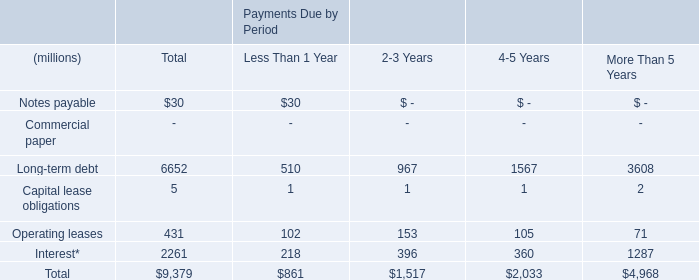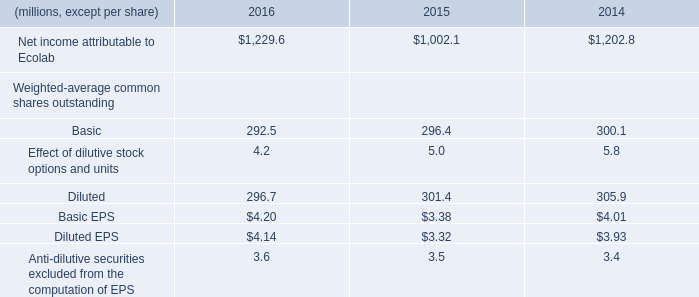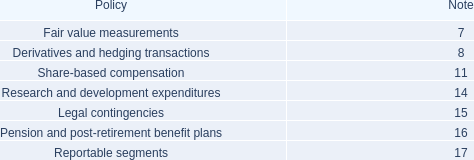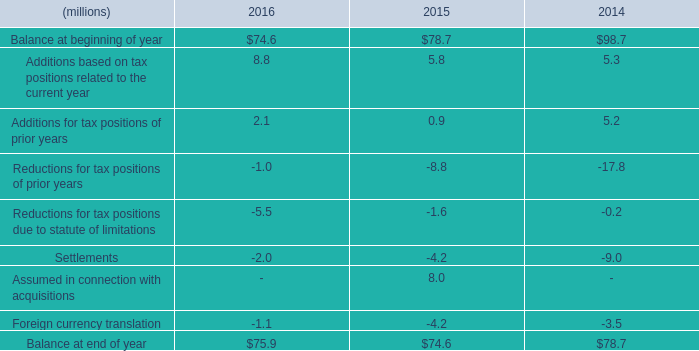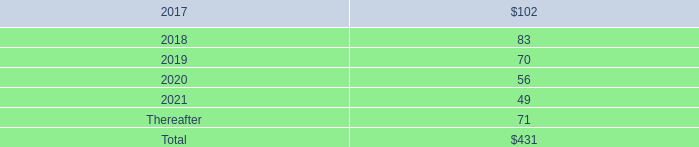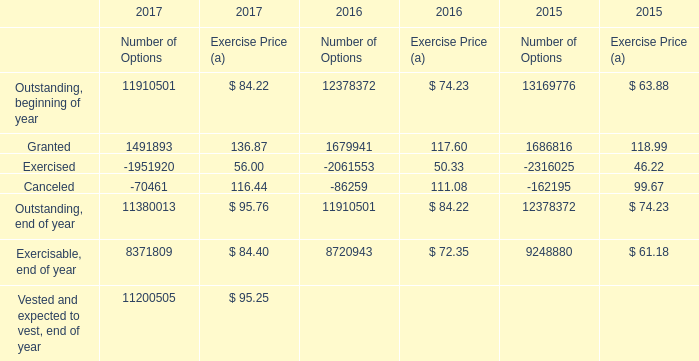what's the total amount of Exercised of 2017 Number of Options, and Net income attributable to Ecolab of 2016 ? 
Computations: (1951920.0 + 1229.6)
Answer: 1953149.6. 